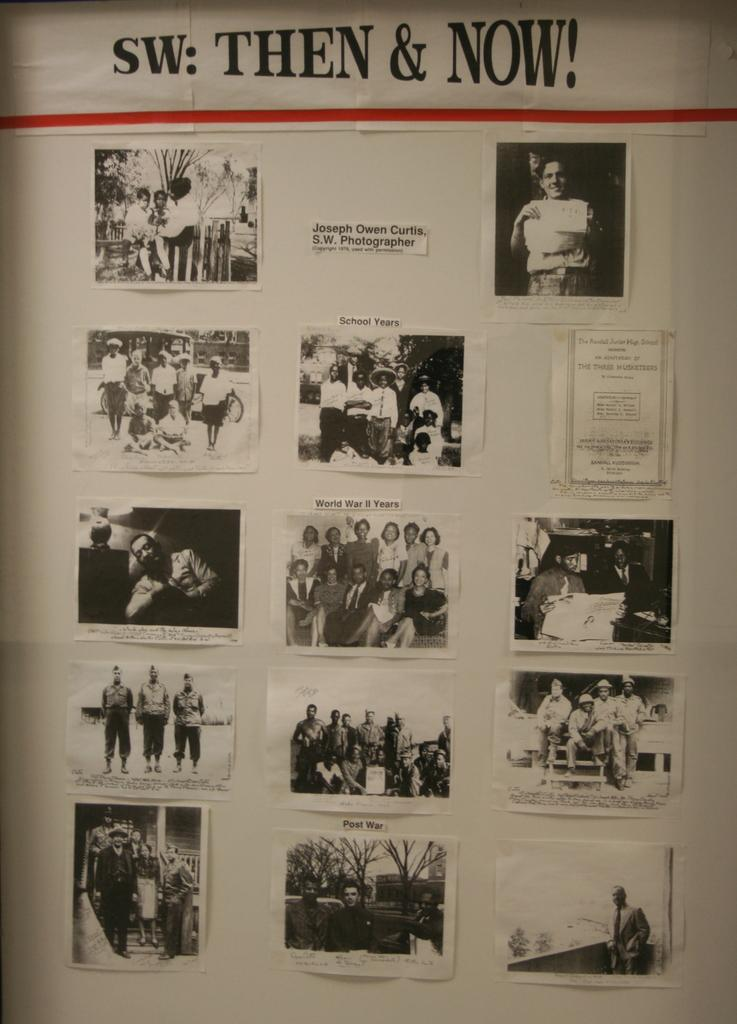What is the white object in the image? The white object in the image appears to be a paper. What can be found on the paper? The paper contains text and pictures. What subjects are depicted in the pictures on the paper? The pictures depict a group of persons, trees, and other objects. Can you see a quiver in the image? There is no quiver present in the image. Is there a guitar being played by the group of persons in the image? The images on the paper do not show any musical instruments, such as a guitar, being played by the group of persons. 